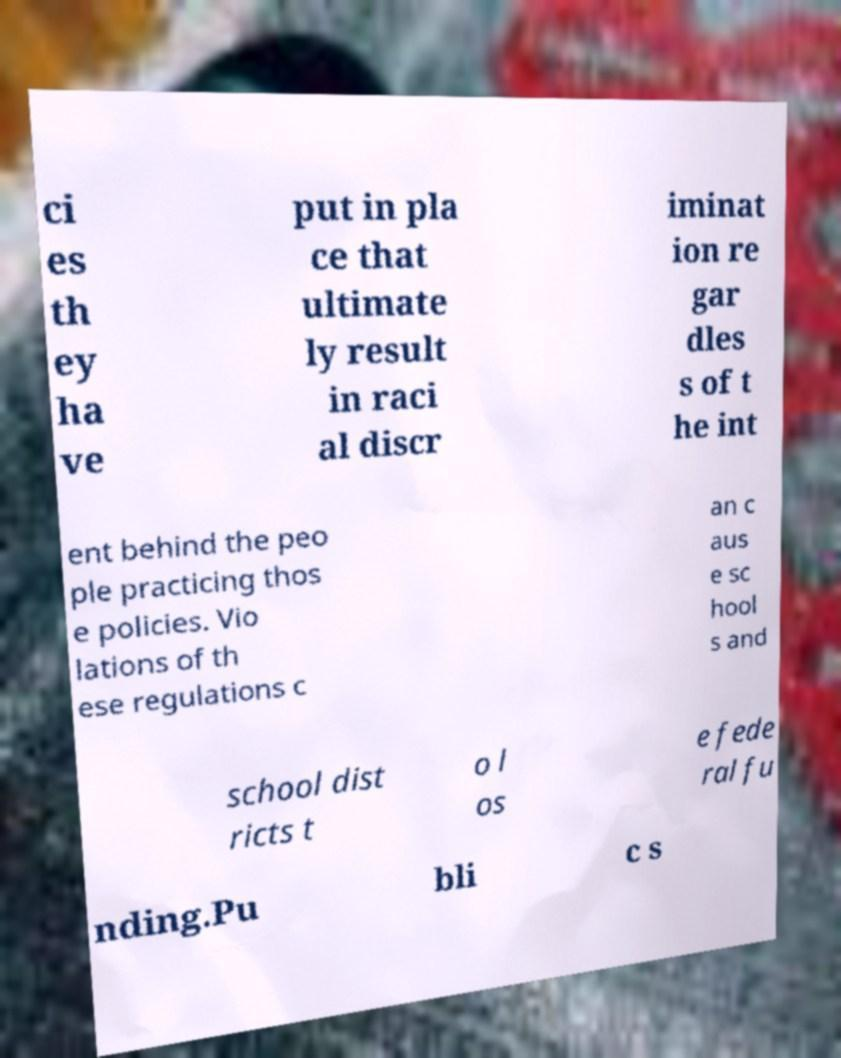For documentation purposes, I need the text within this image transcribed. Could you provide that? ci es th ey ha ve put in pla ce that ultimate ly result in raci al discr iminat ion re gar dles s of t he int ent behind the peo ple practicing thos e policies. Vio lations of th ese regulations c an c aus e sc hool s and school dist ricts t o l os e fede ral fu nding.Pu bli c s 